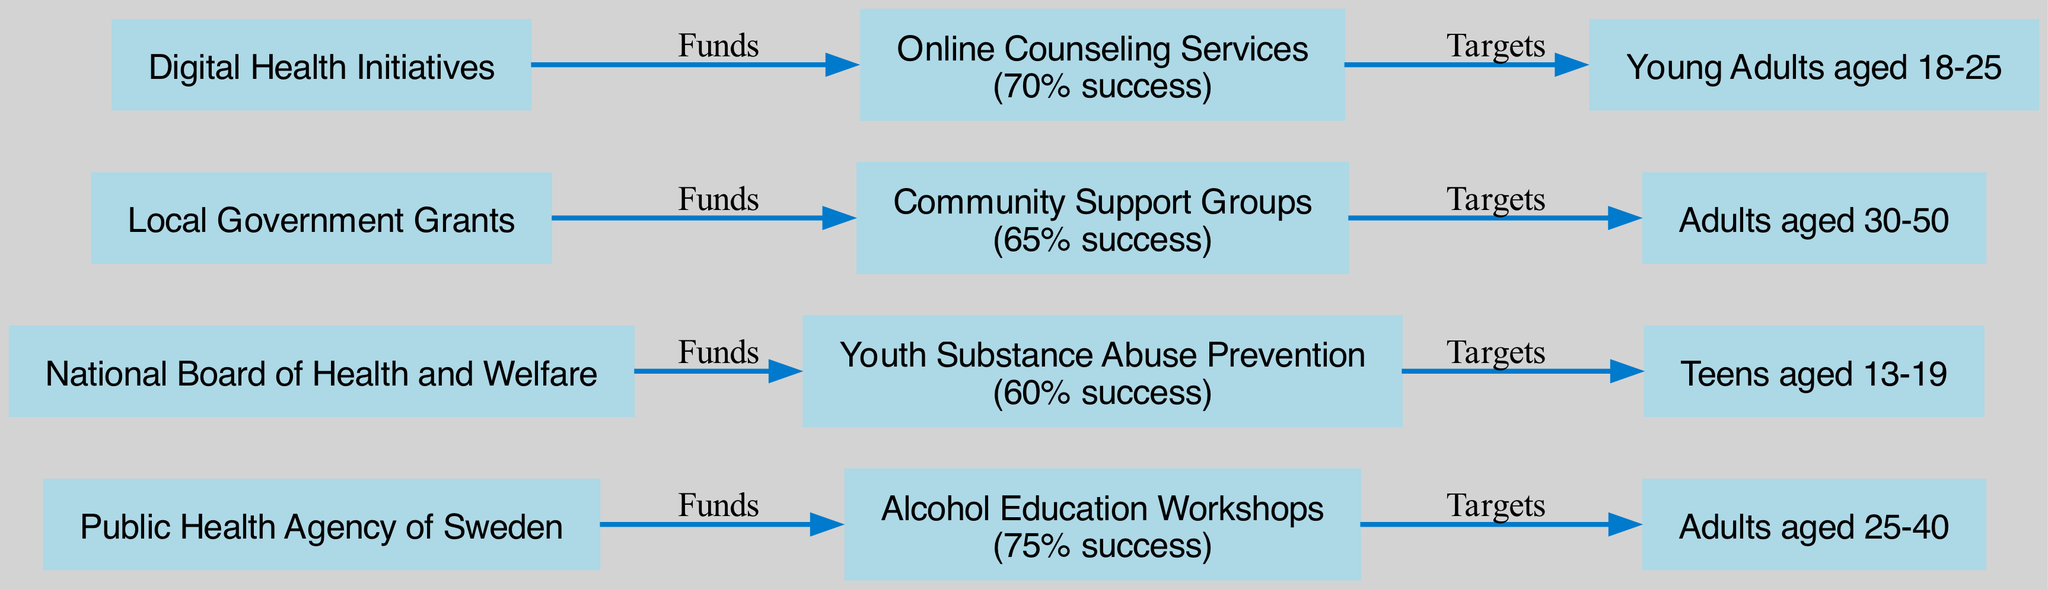What is the success rate of Alcohol Education Workshops? The success rate is explicitly indicated alongside the node of "Alcohol Education Workshops" in the diagram, which states "75% success."
Answer: 75% How many intervention programs are funded by the National Board of Health and Welfare? By reviewing the nodes connected to the "National Board of Health and Welfare" funding source, we see only one intervention program, which is "Youth Substance Abuse Prevention."
Answer: 1 Which demographic is targeted by Online Counseling Services? The node connected to "Online Counseling Services" indicates that it targets "Young Adults aged 18-25."
Answer: Young Adults aged 18-25 What intervention program has the highest success rate? Comparing the success rates of all intervention programs listed in the diagram, "Alcohol Education Workshops" has the highest rate at 75%.
Answer: Alcohol Education Workshops How does Community Support Groups receive funding? The diagram illustrates the connection between "Local Government Grants" and "Community Support Groups," indicating that it receives funds from this source.
Answer: Local Government Grants What is the success rate of Youth Substance Abuse Prevention? The diagram specifies that the success rate for "Youth Substance Abuse Prevention" is indicated as "60% success."
Answer: 60% Which intervention has a success rate lower than 70%? By evaluating each program's success rates visually represented in the diagram, both "Youth Substance Abuse Prevention" (60%) and "Community Support Groups" (65%) have rates lower than 70%.
Answer: Youth Substance Abuse Prevention, Community Support Groups What participant demographic do Alcohol Education Workshops focus on? The demographic node connected to "Alcohol Education Workshops" in the diagram states "Adults aged 25-40," indicating the targeted group for this intervention.
Answer: Adults aged 25-40 How are the intervention programs visualized in terms of funding source? The diagram's structure shows arrows connecting funding sources to specific interventions, visually representing the flow of funds directing towards each program.
Answer: Through directional arrows 